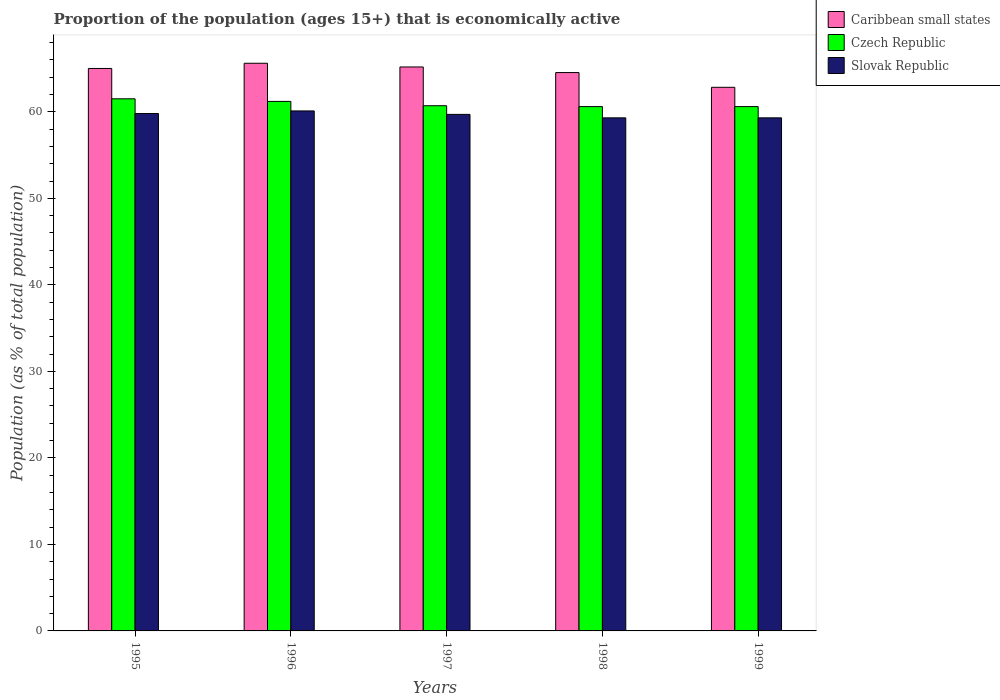How many different coloured bars are there?
Your answer should be very brief. 3. Are the number of bars on each tick of the X-axis equal?
Offer a terse response. Yes. How many bars are there on the 1st tick from the right?
Keep it short and to the point. 3. What is the label of the 3rd group of bars from the left?
Offer a very short reply. 1997. What is the proportion of the population that is economically active in Slovak Republic in 1995?
Provide a short and direct response. 59.8. Across all years, what is the maximum proportion of the population that is economically active in Czech Republic?
Your answer should be compact. 61.5. Across all years, what is the minimum proportion of the population that is economically active in Slovak Republic?
Make the answer very short. 59.3. What is the total proportion of the population that is economically active in Slovak Republic in the graph?
Offer a terse response. 298.2. What is the difference between the proportion of the population that is economically active in Caribbean small states in 1997 and that in 1998?
Provide a short and direct response. 0.65. What is the difference between the proportion of the population that is economically active in Czech Republic in 1998 and the proportion of the population that is economically active in Slovak Republic in 1999?
Provide a short and direct response. 1.3. What is the average proportion of the population that is economically active in Caribbean small states per year?
Provide a succinct answer. 64.63. In the year 1999, what is the difference between the proportion of the population that is economically active in Czech Republic and proportion of the population that is economically active in Slovak Republic?
Your answer should be compact. 1.3. What is the ratio of the proportion of the population that is economically active in Czech Republic in 1996 to that in 1997?
Provide a succinct answer. 1.01. Is the proportion of the population that is economically active in Slovak Republic in 1995 less than that in 1997?
Provide a short and direct response. No. What is the difference between the highest and the second highest proportion of the population that is economically active in Czech Republic?
Offer a terse response. 0.3. What is the difference between the highest and the lowest proportion of the population that is economically active in Czech Republic?
Provide a succinct answer. 0.9. In how many years, is the proportion of the population that is economically active in Caribbean small states greater than the average proportion of the population that is economically active in Caribbean small states taken over all years?
Keep it short and to the point. 3. Is the sum of the proportion of the population that is economically active in Slovak Republic in 1996 and 1998 greater than the maximum proportion of the population that is economically active in Caribbean small states across all years?
Ensure brevity in your answer.  Yes. What does the 2nd bar from the left in 1998 represents?
Keep it short and to the point. Czech Republic. What does the 2nd bar from the right in 1997 represents?
Keep it short and to the point. Czech Republic. How many bars are there?
Ensure brevity in your answer.  15. How many years are there in the graph?
Your answer should be very brief. 5. Are the values on the major ticks of Y-axis written in scientific E-notation?
Keep it short and to the point. No. Does the graph contain any zero values?
Make the answer very short. No. How many legend labels are there?
Make the answer very short. 3. How are the legend labels stacked?
Your answer should be very brief. Vertical. What is the title of the graph?
Provide a short and direct response. Proportion of the population (ages 15+) that is economically active. Does "Middle East & North Africa (all income levels)" appear as one of the legend labels in the graph?
Offer a very short reply. No. What is the label or title of the Y-axis?
Your answer should be very brief. Population (as % of total population). What is the Population (as % of total population) in Caribbean small states in 1995?
Give a very brief answer. 65.01. What is the Population (as % of total population) of Czech Republic in 1995?
Provide a short and direct response. 61.5. What is the Population (as % of total population) of Slovak Republic in 1995?
Offer a terse response. 59.8. What is the Population (as % of total population) of Caribbean small states in 1996?
Your answer should be compact. 65.61. What is the Population (as % of total population) in Czech Republic in 1996?
Your answer should be very brief. 61.2. What is the Population (as % of total population) of Slovak Republic in 1996?
Ensure brevity in your answer.  60.1. What is the Population (as % of total population) of Caribbean small states in 1997?
Offer a terse response. 65.18. What is the Population (as % of total population) in Czech Republic in 1997?
Keep it short and to the point. 60.7. What is the Population (as % of total population) in Slovak Republic in 1997?
Your answer should be very brief. 59.7. What is the Population (as % of total population) of Caribbean small states in 1998?
Your answer should be compact. 64.53. What is the Population (as % of total population) of Czech Republic in 1998?
Offer a very short reply. 60.6. What is the Population (as % of total population) of Slovak Republic in 1998?
Keep it short and to the point. 59.3. What is the Population (as % of total population) of Caribbean small states in 1999?
Your response must be concise. 62.83. What is the Population (as % of total population) in Czech Republic in 1999?
Make the answer very short. 60.6. What is the Population (as % of total population) of Slovak Republic in 1999?
Make the answer very short. 59.3. Across all years, what is the maximum Population (as % of total population) in Caribbean small states?
Make the answer very short. 65.61. Across all years, what is the maximum Population (as % of total population) of Czech Republic?
Give a very brief answer. 61.5. Across all years, what is the maximum Population (as % of total population) in Slovak Republic?
Ensure brevity in your answer.  60.1. Across all years, what is the minimum Population (as % of total population) in Caribbean small states?
Your answer should be very brief. 62.83. Across all years, what is the minimum Population (as % of total population) of Czech Republic?
Provide a short and direct response. 60.6. Across all years, what is the minimum Population (as % of total population) in Slovak Republic?
Give a very brief answer. 59.3. What is the total Population (as % of total population) of Caribbean small states in the graph?
Offer a terse response. 323.16. What is the total Population (as % of total population) of Czech Republic in the graph?
Keep it short and to the point. 304.6. What is the total Population (as % of total population) of Slovak Republic in the graph?
Offer a terse response. 298.2. What is the difference between the Population (as % of total population) of Caribbean small states in 1995 and that in 1996?
Ensure brevity in your answer.  -0.6. What is the difference between the Population (as % of total population) of Czech Republic in 1995 and that in 1996?
Your response must be concise. 0.3. What is the difference between the Population (as % of total population) in Caribbean small states in 1995 and that in 1997?
Your response must be concise. -0.17. What is the difference between the Population (as % of total population) in Caribbean small states in 1995 and that in 1998?
Give a very brief answer. 0.47. What is the difference between the Population (as % of total population) in Czech Republic in 1995 and that in 1998?
Provide a succinct answer. 0.9. What is the difference between the Population (as % of total population) in Caribbean small states in 1995 and that in 1999?
Provide a succinct answer. 2.18. What is the difference between the Population (as % of total population) of Caribbean small states in 1996 and that in 1997?
Make the answer very short. 0.43. What is the difference between the Population (as % of total population) in Czech Republic in 1996 and that in 1997?
Keep it short and to the point. 0.5. What is the difference between the Population (as % of total population) in Slovak Republic in 1996 and that in 1997?
Provide a short and direct response. 0.4. What is the difference between the Population (as % of total population) in Caribbean small states in 1996 and that in 1998?
Your answer should be compact. 1.08. What is the difference between the Population (as % of total population) in Caribbean small states in 1996 and that in 1999?
Give a very brief answer. 2.78. What is the difference between the Population (as % of total population) in Czech Republic in 1996 and that in 1999?
Offer a terse response. 0.6. What is the difference between the Population (as % of total population) of Slovak Republic in 1996 and that in 1999?
Ensure brevity in your answer.  0.8. What is the difference between the Population (as % of total population) in Caribbean small states in 1997 and that in 1998?
Offer a very short reply. 0.65. What is the difference between the Population (as % of total population) of Czech Republic in 1997 and that in 1998?
Keep it short and to the point. 0.1. What is the difference between the Population (as % of total population) in Slovak Republic in 1997 and that in 1998?
Your answer should be compact. 0.4. What is the difference between the Population (as % of total population) of Caribbean small states in 1997 and that in 1999?
Provide a short and direct response. 2.35. What is the difference between the Population (as % of total population) of Caribbean small states in 1998 and that in 1999?
Provide a short and direct response. 1.7. What is the difference between the Population (as % of total population) of Czech Republic in 1998 and that in 1999?
Offer a very short reply. 0. What is the difference between the Population (as % of total population) of Caribbean small states in 1995 and the Population (as % of total population) of Czech Republic in 1996?
Keep it short and to the point. 3.81. What is the difference between the Population (as % of total population) of Caribbean small states in 1995 and the Population (as % of total population) of Slovak Republic in 1996?
Make the answer very short. 4.91. What is the difference between the Population (as % of total population) of Caribbean small states in 1995 and the Population (as % of total population) of Czech Republic in 1997?
Make the answer very short. 4.31. What is the difference between the Population (as % of total population) in Caribbean small states in 1995 and the Population (as % of total population) in Slovak Republic in 1997?
Make the answer very short. 5.31. What is the difference between the Population (as % of total population) of Caribbean small states in 1995 and the Population (as % of total population) of Czech Republic in 1998?
Offer a very short reply. 4.41. What is the difference between the Population (as % of total population) of Caribbean small states in 1995 and the Population (as % of total population) of Slovak Republic in 1998?
Your response must be concise. 5.71. What is the difference between the Population (as % of total population) in Caribbean small states in 1995 and the Population (as % of total population) in Czech Republic in 1999?
Ensure brevity in your answer.  4.41. What is the difference between the Population (as % of total population) in Caribbean small states in 1995 and the Population (as % of total population) in Slovak Republic in 1999?
Keep it short and to the point. 5.71. What is the difference between the Population (as % of total population) of Caribbean small states in 1996 and the Population (as % of total population) of Czech Republic in 1997?
Your response must be concise. 4.91. What is the difference between the Population (as % of total population) in Caribbean small states in 1996 and the Population (as % of total population) in Slovak Republic in 1997?
Your answer should be very brief. 5.91. What is the difference between the Population (as % of total population) in Czech Republic in 1996 and the Population (as % of total population) in Slovak Republic in 1997?
Offer a terse response. 1.5. What is the difference between the Population (as % of total population) in Caribbean small states in 1996 and the Population (as % of total population) in Czech Republic in 1998?
Provide a short and direct response. 5.01. What is the difference between the Population (as % of total population) of Caribbean small states in 1996 and the Population (as % of total population) of Slovak Republic in 1998?
Offer a very short reply. 6.31. What is the difference between the Population (as % of total population) in Caribbean small states in 1996 and the Population (as % of total population) in Czech Republic in 1999?
Offer a terse response. 5.01. What is the difference between the Population (as % of total population) of Caribbean small states in 1996 and the Population (as % of total population) of Slovak Republic in 1999?
Keep it short and to the point. 6.31. What is the difference between the Population (as % of total population) in Czech Republic in 1996 and the Population (as % of total population) in Slovak Republic in 1999?
Make the answer very short. 1.9. What is the difference between the Population (as % of total population) in Caribbean small states in 1997 and the Population (as % of total population) in Czech Republic in 1998?
Provide a short and direct response. 4.58. What is the difference between the Population (as % of total population) of Caribbean small states in 1997 and the Population (as % of total population) of Slovak Republic in 1998?
Your answer should be compact. 5.88. What is the difference between the Population (as % of total population) of Czech Republic in 1997 and the Population (as % of total population) of Slovak Republic in 1998?
Keep it short and to the point. 1.4. What is the difference between the Population (as % of total population) of Caribbean small states in 1997 and the Population (as % of total population) of Czech Republic in 1999?
Provide a short and direct response. 4.58. What is the difference between the Population (as % of total population) in Caribbean small states in 1997 and the Population (as % of total population) in Slovak Republic in 1999?
Provide a short and direct response. 5.88. What is the difference between the Population (as % of total population) of Caribbean small states in 1998 and the Population (as % of total population) of Czech Republic in 1999?
Make the answer very short. 3.93. What is the difference between the Population (as % of total population) of Caribbean small states in 1998 and the Population (as % of total population) of Slovak Republic in 1999?
Your answer should be very brief. 5.23. What is the average Population (as % of total population) of Caribbean small states per year?
Provide a succinct answer. 64.63. What is the average Population (as % of total population) in Czech Republic per year?
Keep it short and to the point. 60.92. What is the average Population (as % of total population) in Slovak Republic per year?
Offer a very short reply. 59.64. In the year 1995, what is the difference between the Population (as % of total population) in Caribbean small states and Population (as % of total population) in Czech Republic?
Make the answer very short. 3.51. In the year 1995, what is the difference between the Population (as % of total population) of Caribbean small states and Population (as % of total population) of Slovak Republic?
Offer a terse response. 5.21. In the year 1995, what is the difference between the Population (as % of total population) in Czech Republic and Population (as % of total population) in Slovak Republic?
Offer a terse response. 1.7. In the year 1996, what is the difference between the Population (as % of total population) in Caribbean small states and Population (as % of total population) in Czech Republic?
Your response must be concise. 4.41. In the year 1996, what is the difference between the Population (as % of total population) in Caribbean small states and Population (as % of total population) in Slovak Republic?
Keep it short and to the point. 5.51. In the year 1997, what is the difference between the Population (as % of total population) of Caribbean small states and Population (as % of total population) of Czech Republic?
Your answer should be very brief. 4.48. In the year 1997, what is the difference between the Population (as % of total population) of Caribbean small states and Population (as % of total population) of Slovak Republic?
Offer a very short reply. 5.48. In the year 1998, what is the difference between the Population (as % of total population) of Caribbean small states and Population (as % of total population) of Czech Republic?
Keep it short and to the point. 3.93. In the year 1998, what is the difference between the Population (as % of total population) of Caribbean small states and Population (as % of total population) of Slovak Republic?
Offer a very short reply. 5.23. In the year 1999, what is the difference between the Population (as % of total population) of Caribbean small states and Population (as % of total population) of Czech Republic?
Your response must be concise. 2.23. In the year 1999, what is the difference between the Population (as % of total population) in Caribbean small states and Population (as % of total population) in Slovak Republic?
Keep it short and to the point. 3.53. What is the ratio of the Population (as % of total population) in Caribbean small states in 1995 to that in 1996?
Give a very brief answer. 0.99. What is the ratio of the Population (as % of total population) in Czech Republic in 1995 to that in 1996?
Your response must be concise. 1. What is the ratio of the Population (as % of total population) in Czech Republic in 1995 to that in 1997?
Ensure brevity in your answer.  1.01. What is the ratio of the Population (as % of total population) of Slovak Republic in 1995 to that in 1997?
Your answer should be compact. 1. What is the ratio of the Population (as % of total population) of Caribbean small states in 1995 to that in 1998?
Your answer should be compact. 1.01. What is the ratio of the Population (as % of total population) in Czech Republic in 1995 to that in 1998?
Offer a very short reply. 1.01. What is the ratio of the Population (as % of total population) in Slovak Republic in 1995 to that in 1998?
Offer a very short reply. 1.01. What is the ratio of the Population (as % of total population) of Caribbean small states in 1995 to that in 1999?
Provide a short and direct response. 1.03. What is the ratio of the Population (as % of total population) of Czech Republic in 1995 to that in 1999?
Keep it short and to the point. 1.01. What is the ratio of the Population (as % of total population) of Slovak Republic in 1995 to that in 1999?
Provide a succinct answer. 1.01. What is the ratio of the Population (as % of total population) of Caribbean small states in 1996 to that in 1997?
Provide a succinct answer. 1.01. What is the ratio of the Population (as % of total population) in Czech Republic in 1996 to that in 1997?
Your response must be concise. 1.01. What is the ratio of the Population (as % of total population) in Slovak Republic in 1996 to that in 1997?
Make the answer very short. 1.01. What is the ratio of the Population (as % of total population) in Caribbean small states in 1996 to that in 1998?
Offer a very short reply. 1.02. What is the ratio of the Population (as % of total population) in Czech Republic in 1996 to that in 1998?
Provide a short and direct response. 1.01. What is the ratio of the Population (as % of total population) in Slovak Republic in 1996 to that in 1998?
Keep it short and to the point. 1.01. What is the ratio of the Population (as % of total population) of Caribbean small states in 1996 to that in 1999?
Your response must be concise. 1.04. What is the ratio of the Population (as % of total population) of Czech Republic in 1996 to that in 1999?
Keep it short and to the point. 1.01. What is the ratio of the Population (as % of total population) of Slovak Republic in 1996 to that in 1999?
Your answer should be very brief. 1.01. What is the ratio of the Population (as % of total population) of Caribbean small states in 1997 to that in 1998?
Your response must be concise. 1.01. What is the ratio of the Population (as % of total population) of Caribbean small states in 1997 to that in 1999?
Make the answer very short. 1.04. What is the ratio of the Population (as % of total population) in Czech Republic in 1997 to that in 1999?
Provide a short and direct response. 1. What is the ratio of the Population (as % of total population) of Caribbean small states in 1998 to that in 1999?
Your response must be concise. 1.03. What is the difference between the highest and the second highest Population (as % of total population) of Caribbean small states?
Your answer should be compact. 0.43. What is the difference between the highest and the lowest Population (as % of total population) in Caribbean small states?
Provide a succinct answer. 2.78. What is the difference between the highest and the lowest Population (as % of total population) in Czech Republic?
Keep it short and to the point. 0.9. 